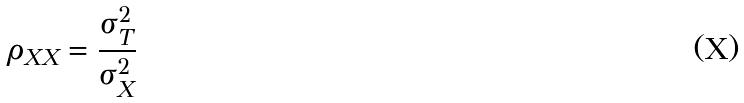Convert formula to latex. <formula><loc_0><loc_0><loc_500><loc_500>\rho _ { X X } = \frac { \sigma _ { T } ^ { 2 } } { \sigma _ { X } ^ { 2 } }</formula> 